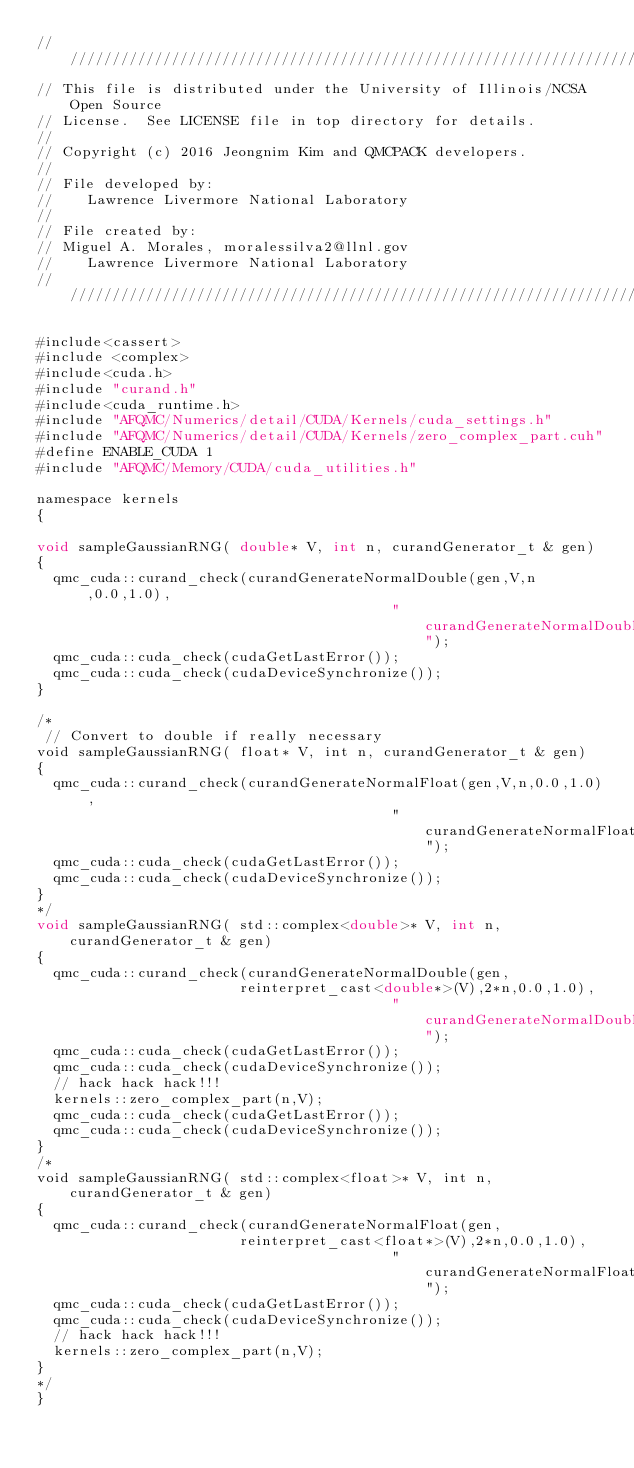Convert code to text. <code><loc_0><loc_0><loc_500><loc_500><_Cuda_>//////////////////////////////////////////////////////////////////////
// This file is distributed under the University of Illinois/NCSA Open Source
// License.  See LICENSE file in top directory for details.
//
// Copyright (c) 2016 Jeongnim Kim and QMCPACK developers.
//
// File developed by:
//    Lawrence Livermore National Laboratory 
//
// File created by:
// Miguel A. Morales, moralessilva2@llnl.gov 
//    Lawrence Livermore National Laboratory 
////////////////////////////////////////////////////////////////////////////////

#include<cassert>
#include <complex>
#include<cuda.h>
#include "curand.h"
#include<cuda_runtime.h>
#include "AFQMC/Numerics/detail/CUDA/Kernels/cuda_settings.h"
#include "AFQMC/Numerics/detail/CUDA/Kernels/zero_complex_part.cuh"
#define ENABLE_CUDA 1
#include "AFQMC/Memory/CUDA/cuda_utilities.h"

namespace kernels
{

void sampleGaussianRNG( double* V, int n, curandGenerator_t & gen) 
{
  qmc_cuda::curand_check(curandGenerateNormalDouble(gen,V,n,0.0,1.0),
                                          "curandGenerateNormalDouble");
  qmc_cuda::cuda_check(cudaGetLastError());
  qmc_cuda::cuda_check(cudaDeviceSynchronize());
}

/*
 // Convert to double if really necessary
void sampleGaussianRNG( float* V, int n, curandGenerator_t & gen) 
{
  qmc_cuda::curand_check(curandGenerateNormalFloat(gen,V,n,0.0,1.0),
                                          "curandGenerateNormalFloat");
  qmc_cuda::cuda_check(cudaGetLastError());
  qmc_cuda::cuda_check(cudaDeviceSynchronize());
}
*/
void sampleGaussianRNG( std::complex<double>* V, int n, curandGenerator_t & gen) 
{
  qmc_cuda::curand_check(curandGenerateNormalDouble(gen,
                        reinterpret_cast<double*>(V),2*n,0.0,1.0),
                                          "curandGenerateNormalDouble");
  qmc_cuda::cuda_check(cudaGetLastError());
  qmc_cuda::cuda_check(cudaDeviceSynchronize());
  // hack hack hack!!!
  kernels::zero_complex_part(n,V);
  qmc_cuda::cuda_check(cudaGetLastError());
  qmc_cuda::cuda_check(cudaDeviceSynchronize());
}
/*
void sampleGaussianRNG( std::complex<float>* V, int n, curandGenerator_t & gen) 
{
  qmc_cuda::curand_check(curandGenerateNormalFloat(gen,
                        reinterpret_cast<float*>(V),2*n,0.0,1.0),
                                          "curandGenerateNormalFloat");
  qmc_cuda::cuda_check(cudaGetLastError());
  qmc_cuda::cuda_check(cudaDeviceSynchronize());
  // hack hack hack!!!
  kernels::zero_complex_part(n,V);
} 
*/
}
</code> 